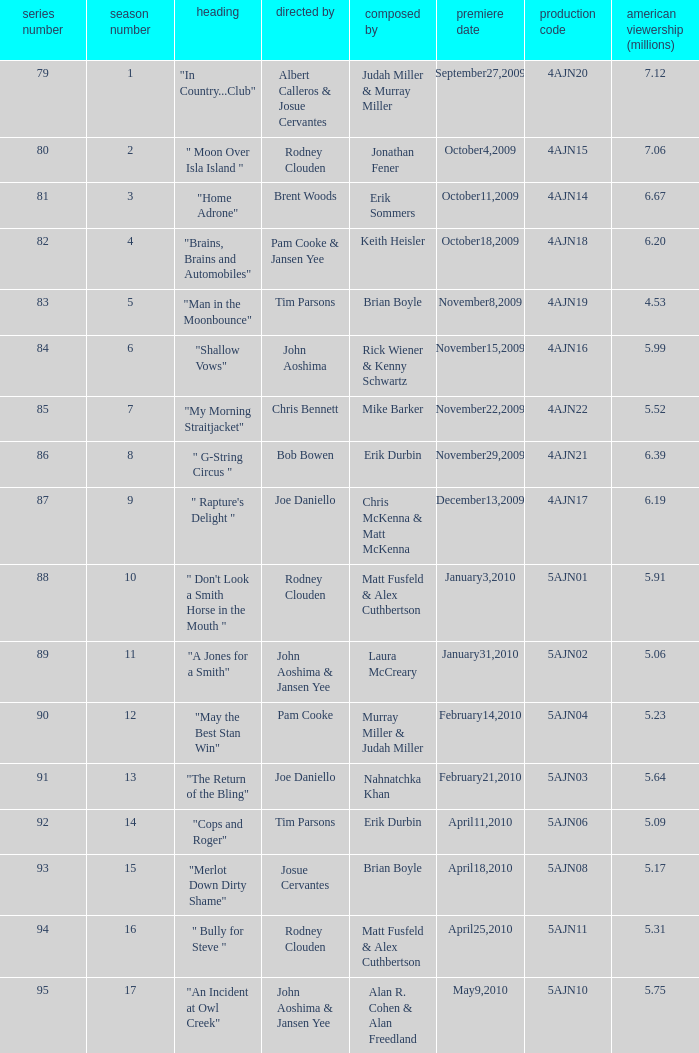Name who wrote the episode directed by  pam cooke & jansen yee Keith Heisler. 